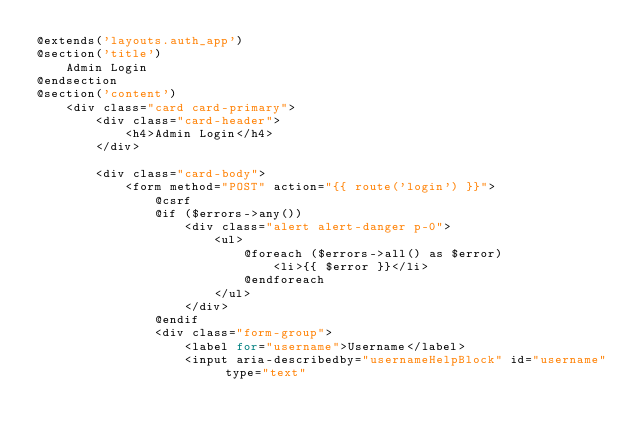<code> <loc_0><loc_0><loc_500><loc_500><_PHP_>@extends('layouts.auth_app')
@section('title')
    Admin Login
@endsection
@section('content')
    <div class="card card-primary">
        <div class="card-header">
            <h4>Admin Login</h4>
        </div>

        <div class="card-body">
            <form method="POST" action="{{ route('login') }}">
                @csrf
                @if ($errors->any())
                    <div class="alert alert-danger p-0">
                        <ul>
                            @foreach ($errors->all() as $error)
                                <li>{{ $error }}</li>
                            @endforeach
                        </ul>
                    </div>
                @endif
                <div class="form-group">
                    <label for="username">Username</label>
                    <input aria-describedby="usernameHelpBlock" id="username" type="text"</code> 